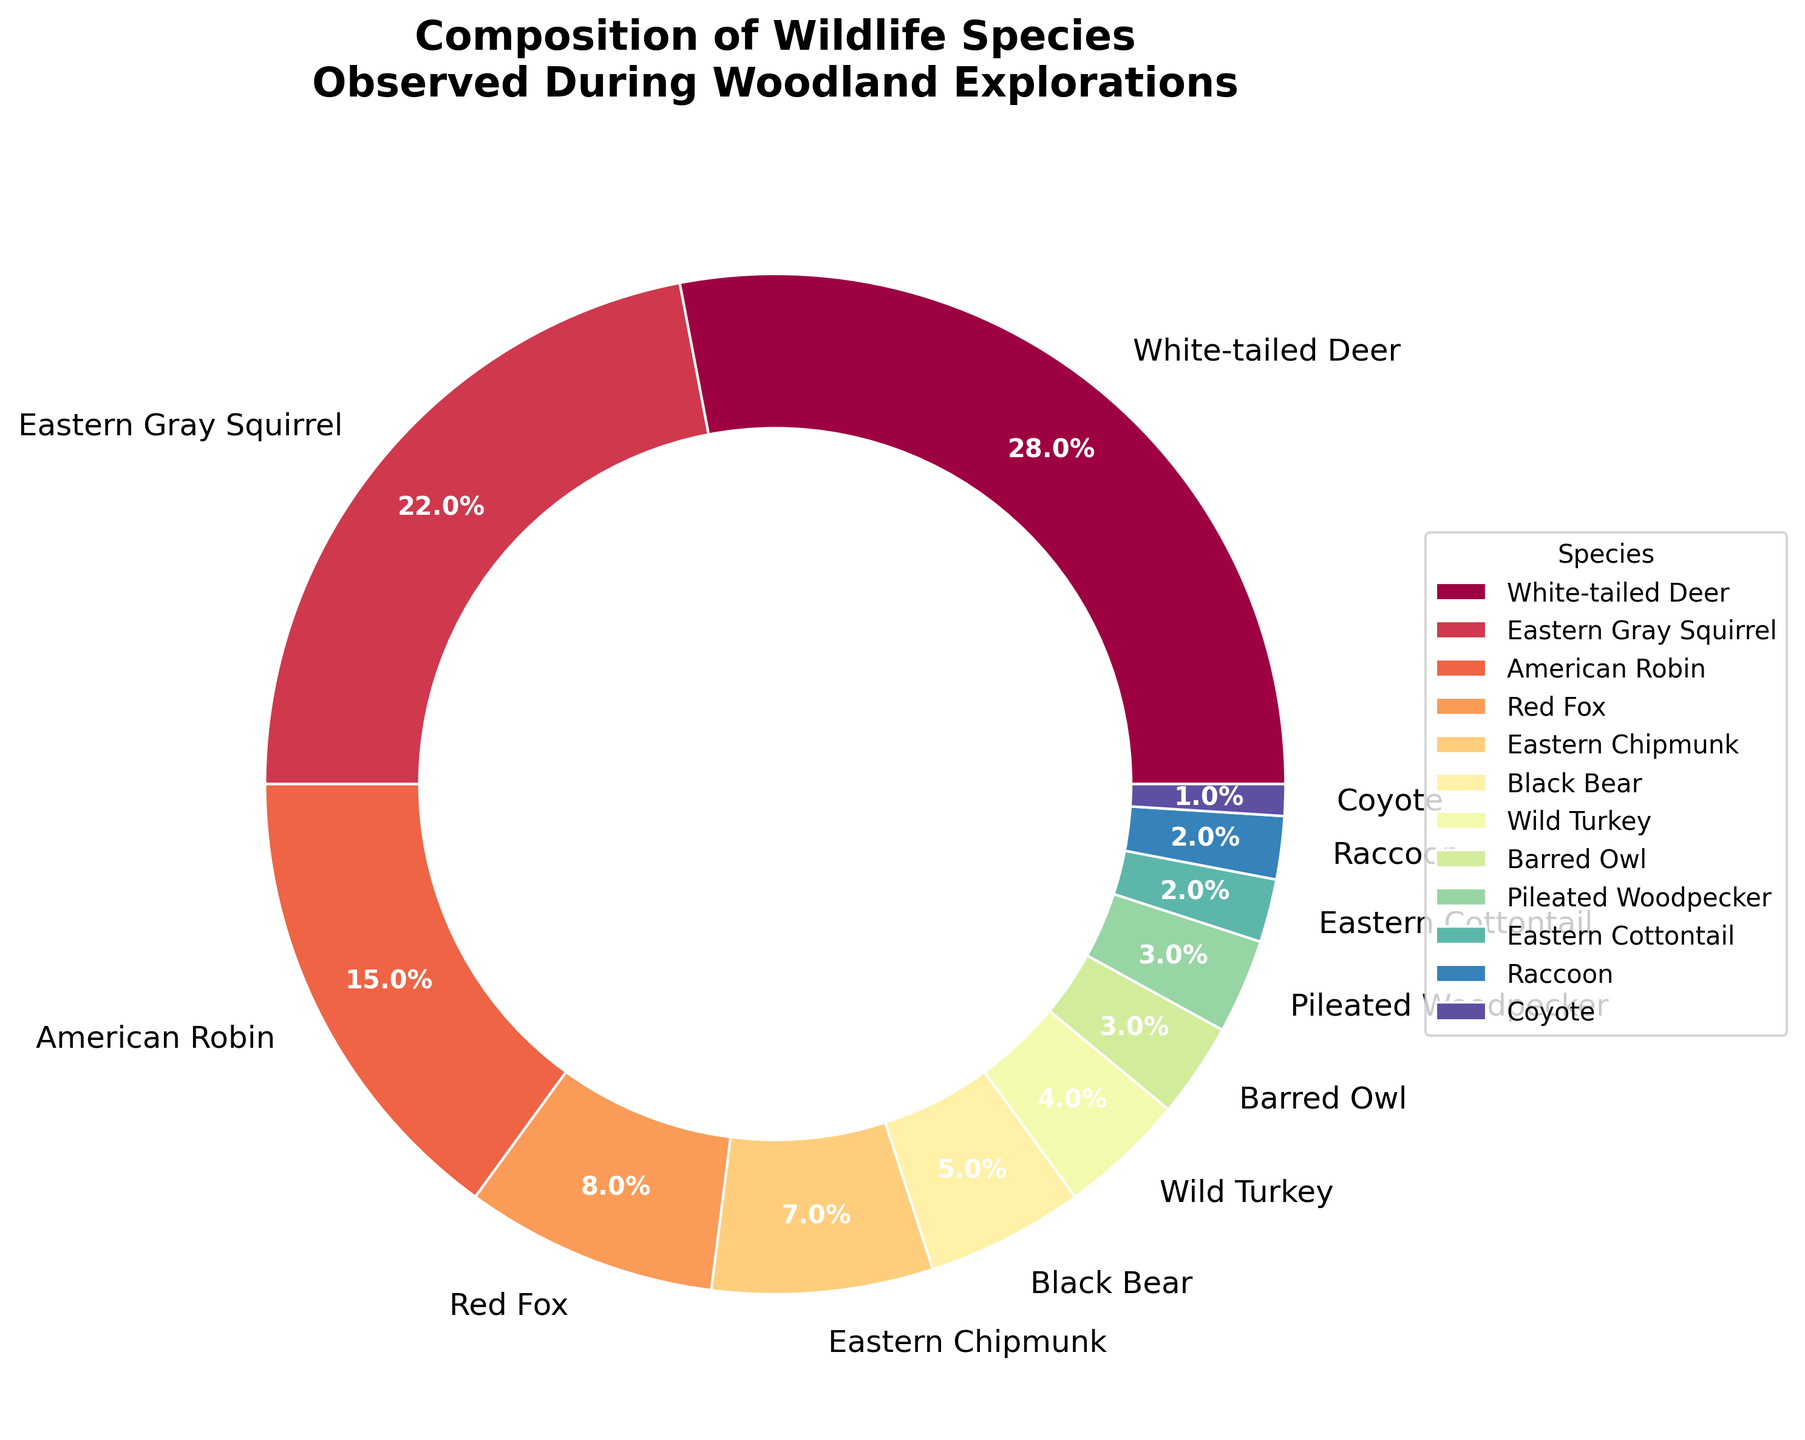What's the most commonly observed species? The most commonly observed species is indicated by the largest slice. White-tailed Deer occupy the largest percentage of 28%.
Answer: White-tailed Deer Which species has a lower percentage than Eastern Gray Squirrel but higher than Black Bear? By analyzing the figure, the Eastern Gray Squirrel has 22% and Black Bear has 5%. The species that fits between these values is the American Robin with 15%.
Answer: American Robin What is the combined percentage of Barred Owl and Pileated Woodpecker? Barred Owl and Pileated Woodpecker each occupy 3%. So, their combined percentage is 3 + 3 = 6%.
Answer: 6% Which species has a similar observation percentage as Eastern Chipmunk? The Eastern Chipmunk has 7%. Among the species, Black Bear has a percentage of 5%, which is closest to 7% and has no other closer observation percentage.
Answer: Black Bear How does the observation of Red Fox compare to Wild Turkey in percentage terms? The Red Fox has an 8% observation rate while Wild Turkey has a 4% rate. Red Fox has twice the observation rate of Wild Turkey.
Answer: Twice as much What is the total percentage of species with less than 5% observations each? The species with less than 5% are Black Bear (5%), Wild Turkey (4%), Barred Owl (3%), Pileated Woodpecker (3%), Eastern Cottontail (2%), Raccoon (2%), and Coyote (1%). They sum to 5 + 4 + 3 + 3 + 2 + 2 + 1 = 20%.
Answer: 20% Which two species combined constitute nearly one-quarter of the observed wildlife? Adding percentages of White-tailed Deer (28%) and Eastern Gray Squirrel (22%) gives us 50%, not near one-quarter. But adding American Robin (15%) and Red Fox (8%) gives us 23%, near one-quarter.
Answer: American Robin and Red Fox Is the percentage of observed Coyotes greater than that of Eastern Cottontail? The percentage for Coyotes is 1%, while for Eastern Cottontail it is 2%. Therefore, Eastern Cottontail has the greater percentage.
Answer: No What can we infer about the diversity of bird species compared to mammal species? Bird species observed include American Robin, Barred Owl, and Pileated Woodpecker. Combining their percentages gives 15 + 3 + 3 = 21%. Mammals, including White-tailed Deer, Eastern Gray Squirrel, Red Fox, Eastern Chipmunk, Black Bear, Eastern Cottontail, Raccoon, and Coyote sum to 28 + 22 + 8 + 7 + 5 + 2 + 2 + 1 = 75%. Mammals have a significantly higher percentage of observations compared to birds, indicating higher diversity.
Answer: Mammals are more diverse What is the percentage difference between the highest observed species and the lowest? The highest observed species is White-tailed Deer with 28%, and the lowest is Coyote with 1%. The difference is 28 - 1 = 27%.
Answer: 27% 